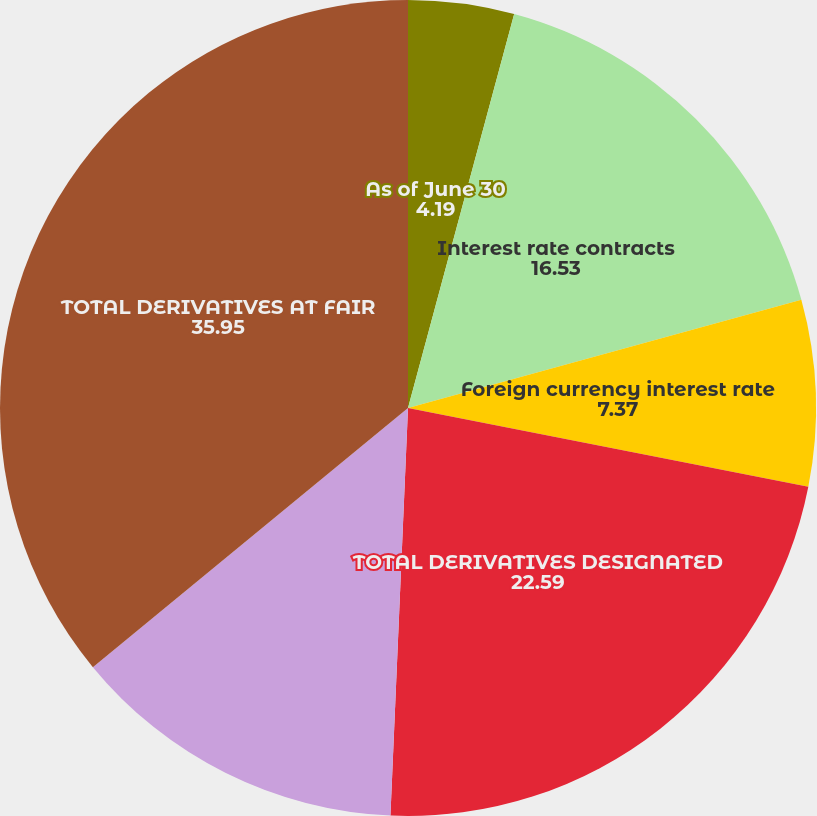Convert chart. <chart><loc_0><loc_0><loc_500><loc_500><pie_chart><fcel>As of June 30<fcel>Interest rate contracts<fcel>Foreign currency interest rate<fcel>TOTAL DERIVATIVES DESIGNATED<fcel>Foreign currency contracts<fcel>TOTAL DERIVATIVES AT FAIR<nl><fcel>4.19%<fcel>16.53%<fcel>7.37%<fcel>22.59%<fcel>13.36%<fcel>35.95%<nl></chart> 